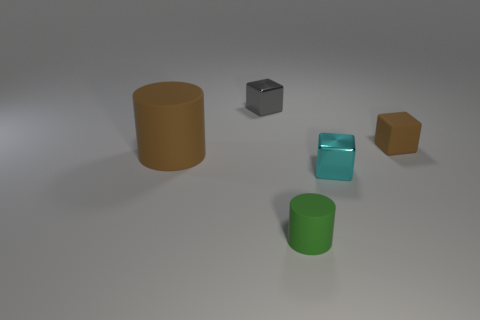What is the small thing that is both left of the tiny cyan metallic block and behind the green cylinder made of?
Your answer should be very brief. Metal. There is a brown object left of the matte block; does it have the same shape as the shiny thing in front of the brown block?
Provide a succinct answer. No. There is a big rubber object that is the same color as the rubber block; what shape is it?
Offer a terse response. Cylinder. How many objects are either shiny things that are behind the tiny rubber block or blue spheres?
Provide a short and direct response. 1. Is the size of the cyan metallic thing the same as the green object?
Ensure brevity in your answer.  Yes. There is a small metal block that is on the right side of the green rubber thing; what color is it?
Make the answer very short. Cyan. There is a cyan thing that is the same material as the gray block; what size is it?
Ensure brevity in your answer.  Small. Is the size of the green thing the same as the rubber thing that is on the left side of the gray metal cube?
Your response must be concise. No. There is a cylinder on the right side of the large thing; what material is it?
Provide a short and direct response. Rubber. There is a matte cylinder behind the green cylinder; what number of rubber things are in front of it?
Provide a succinct answer. 1. 